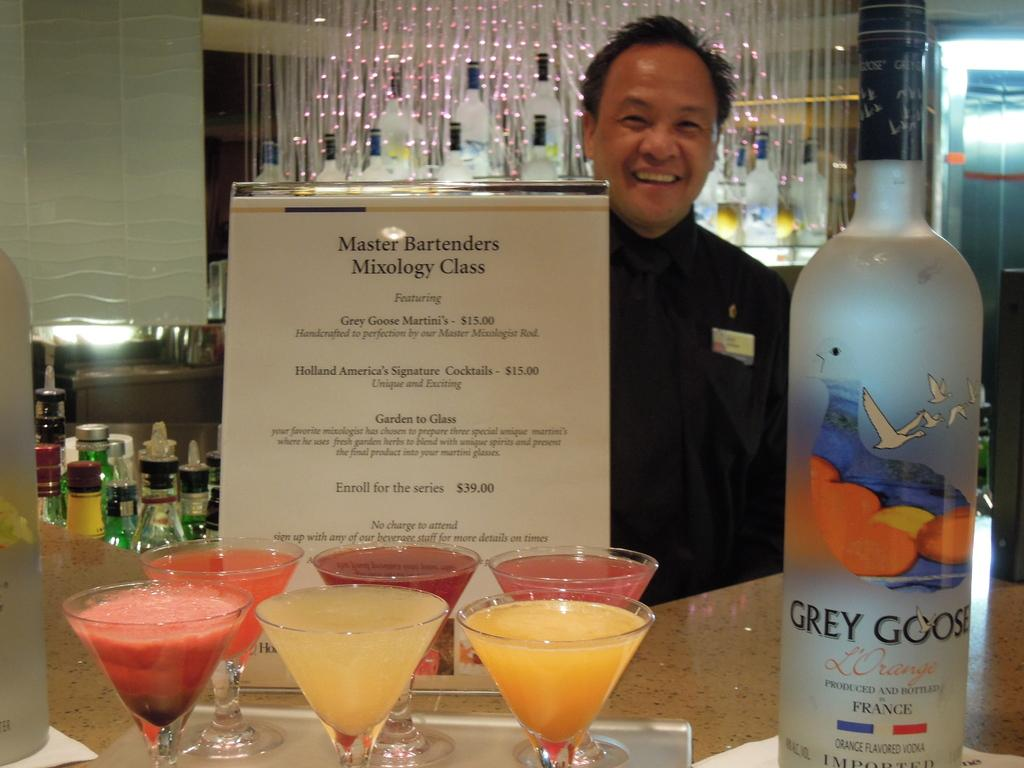Provide a one-sentence caption for the provided image. A bartender poses with a bottle of Grey Goose and a menu for the Master Bartender Mixology Class featuring Grey Goose Martini's for $15.00 as well as other drinks. 